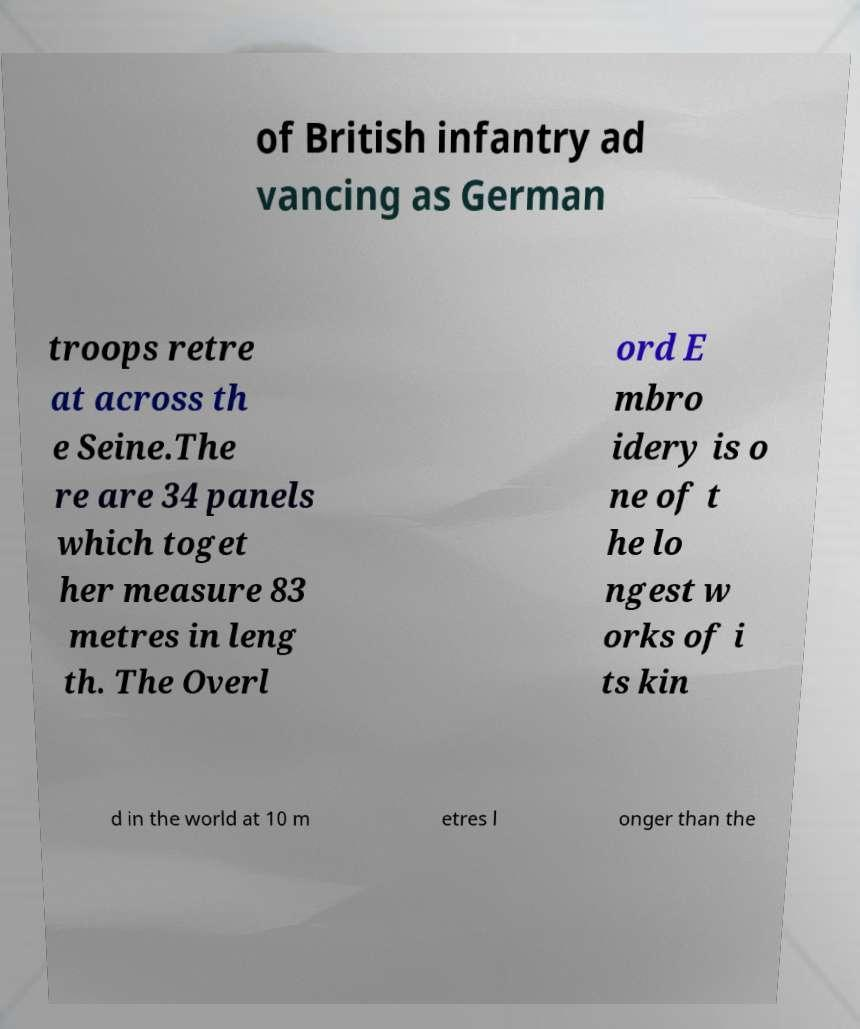What messages or text are displayed in this image? I need them in a readable, typed format. of British infantry ad vancing as German troops retre at across th e Seine.The re are 34 panels which toget her measure 83 metres in leng th. The Overl ord E mbro idery is o ne of t he lo ngest w orks of i ts kin d in the world at 10 m etres l onger than the 